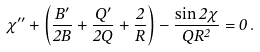<formula> <loc_0><loc_0><loc_500><loc_500>\chi ^ { \prime \prime } + \left ( { \frac { B ^ { \prime } } { 2 B } } + { \frac { Q ^ { \prime } } { 2 Q } } + { \frac { 2 } { R } } \right ) - { \frac { \sin 2 \chi } { Q R ^ { 2 } } } = 0 \, .</formula> 